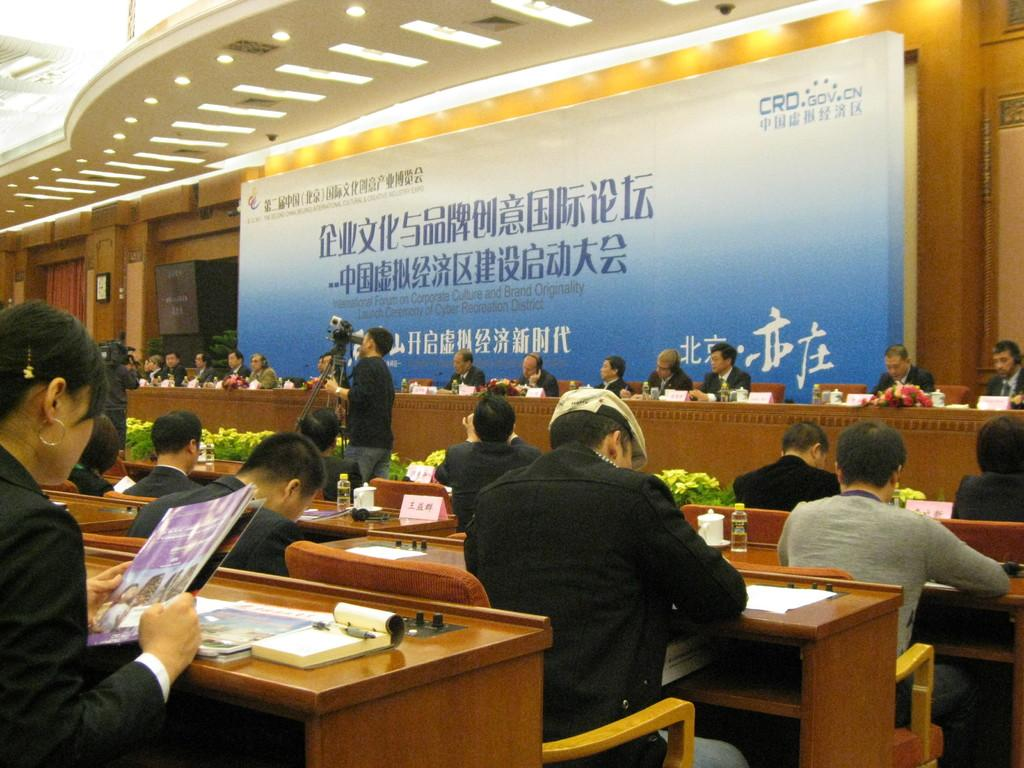What are the people in the image doing? The people in the image are sitting on chairs. Where are the chairs located in relation to the table? The chairs are near a table. What can be seen in the background of the image? There is a banner in the background of the image. What type of spark can be seen coming from the doctor's yarn in the image? There is no doctor or yarn present in the image, and therefore no spark can be observed. 